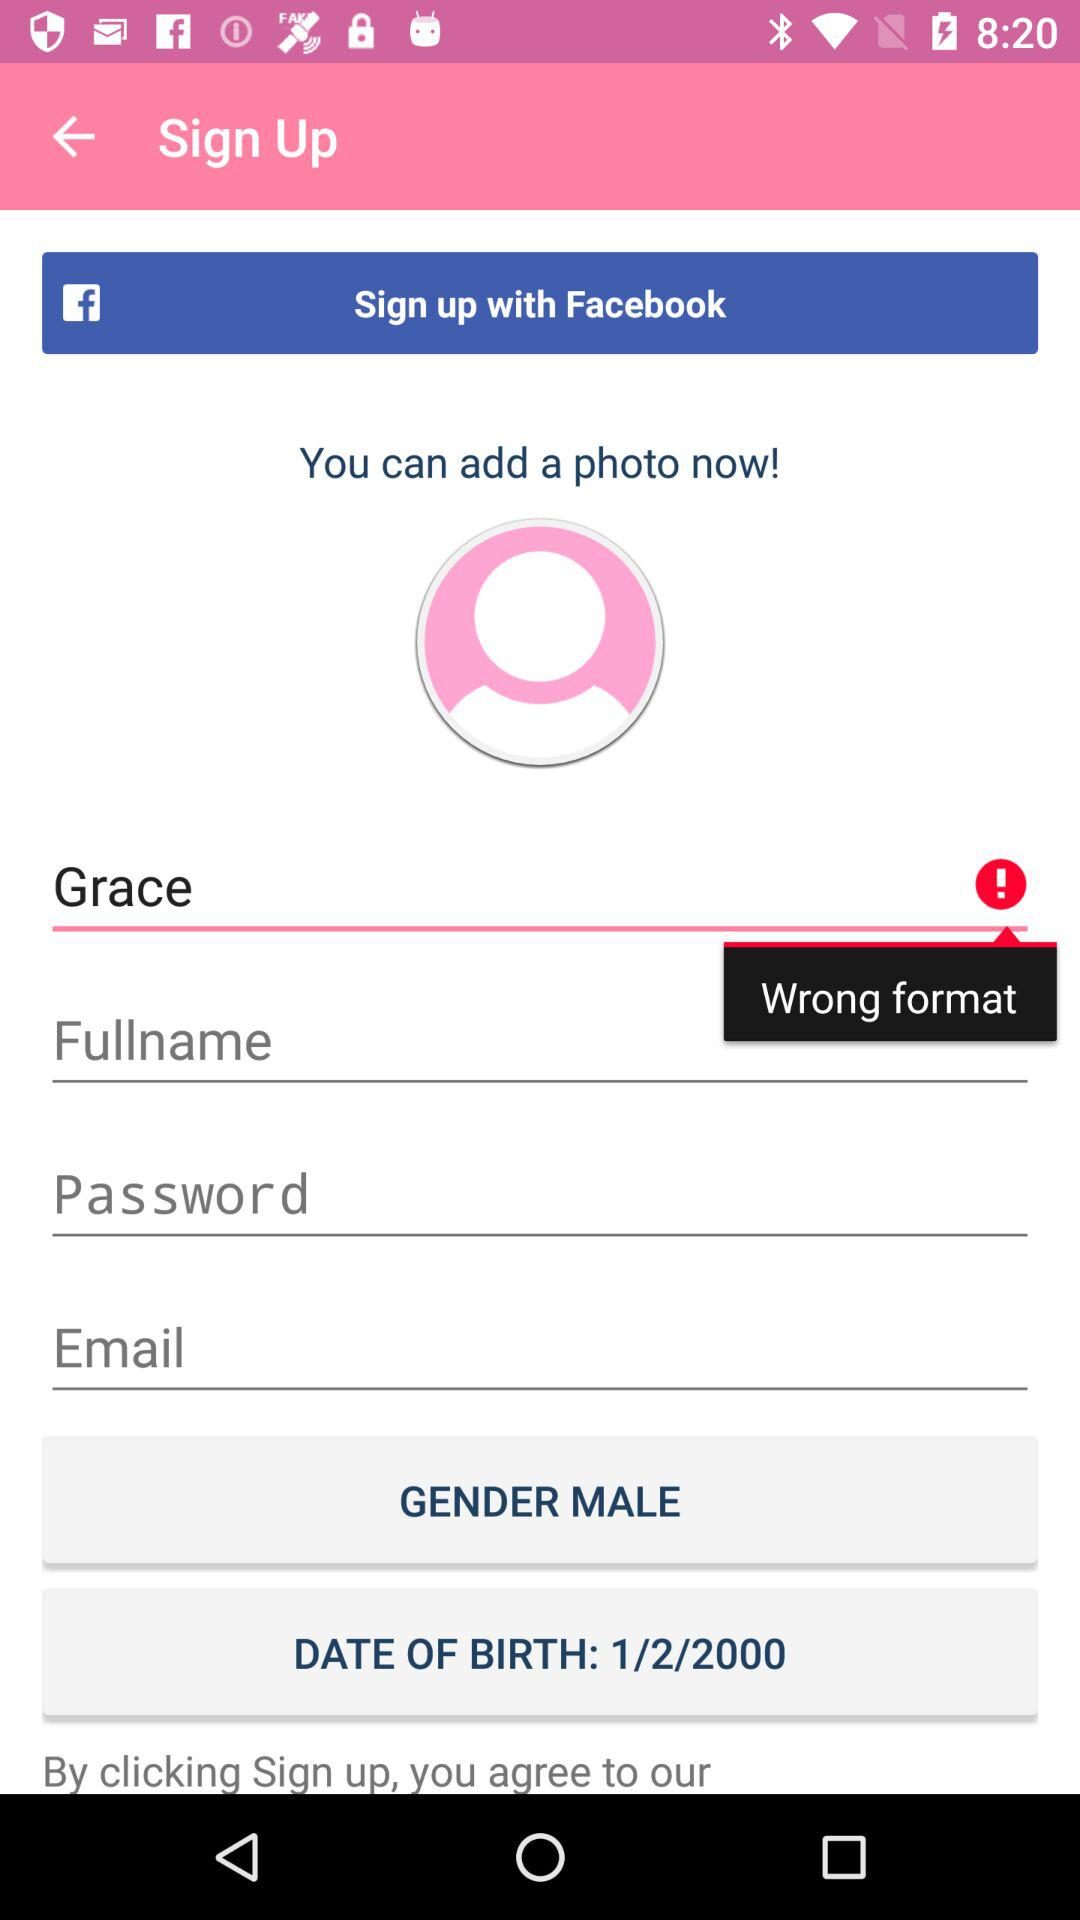With what application can we also sign up? You can also sign up with "Facebook". 